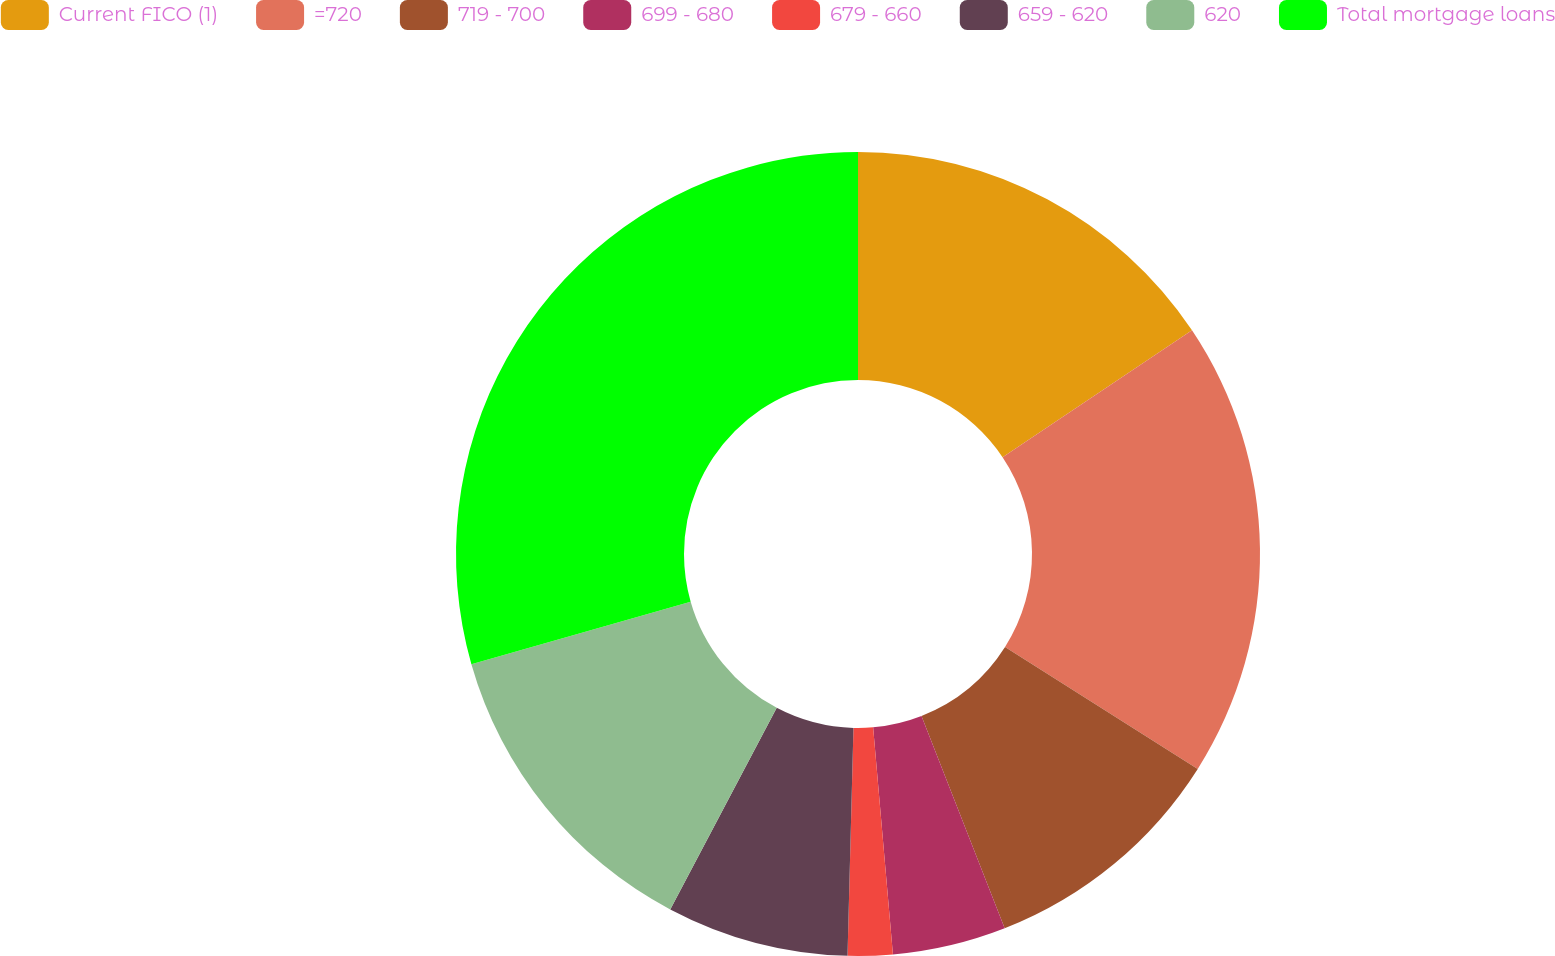<chart> <loc_0><loc_0><loc_500><loc_500><pie_chart><fcel>Current FICO (1)<fcel>=720<fcel>719 - 700<fcel>699 - 680<fcel>679 - 660<fcel>659 - 620<fcel>620<fcel>Total mortgage loans<nl><fcel>15.61%<fcel>18.37%<fcel>10.08%<fcel>4.56%<fcel>1.8%<fcel>7.32%<fcel>12.85%<fcel>29.42%<nl></chart> 